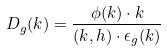<formula> <loc_0><loc_0><loc_500><loc_500>D _ { g } ( k ) = \frac { \phi ( k ) \cdot k } { ( k , h ) \cdot \epsilon _ { g } ( k ) }</formula> 